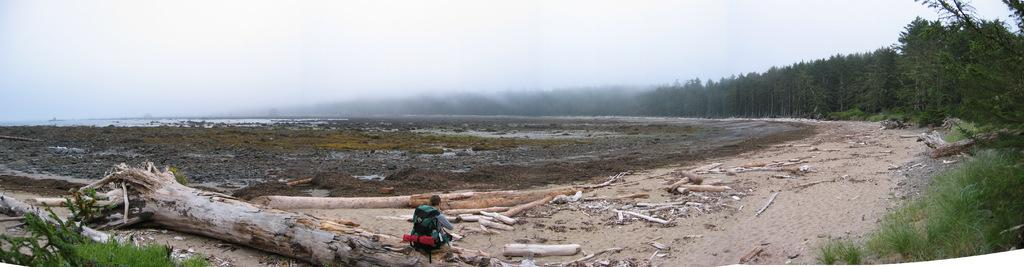What is the person in the image doing? The person is sitting on a fallen tree in the image. What can be seen on the ground in the image? There are wooden objects on the ground in the image. What type of vegetation is present in the image? Grass and plants are visible in the image. What other natural elements can be seen in the image? Trees and water are visible in the image. What is visible in the background of the image? The sky is visible in the image. What type of yam is being used as a basketball in the image? There is no yam or basketball present in the image. How is the person in the image covering themselves from the sun? The image does not show the person covering themselves from the sun, nor is there any indication of a cover in the image. 